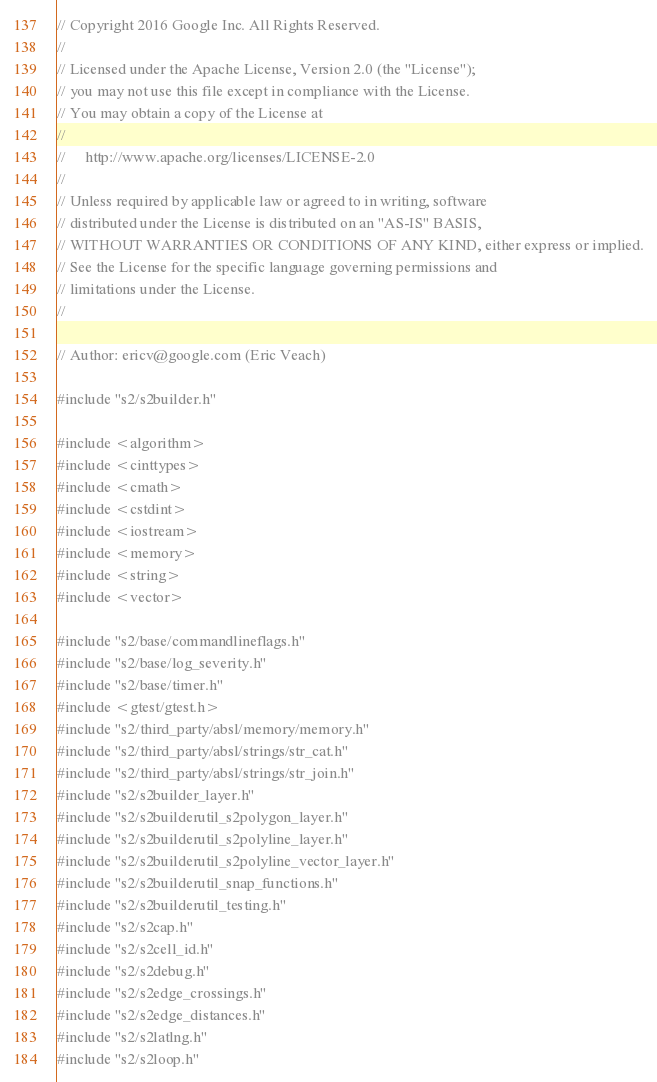Convert code to text. <code><loc_0><loc_0><loc_500><loc_500><_C++_>// Copyright 2016 Google Inc. All Rights Reserved.
//
// Licensed under the Apache License, Version 2.0 (the "License");
// you may not use this file except in compliance with the License.
// You may obtain a copy of the License at
//
//     http://www.apache.org/licenses/LICENSE-2.0
//
// Unless required by applicable law or agreed to in writing, software
// distributed under the License is distributed on an "AS-IS" BASIS,
// WITHOUT WARRANTIES OR CONDITIONS OF ANY KIND, either express or implied.
// See the License for the specific language governing permissions and
// limitations under the License.
//

// Author: ericv@google.com (Eric Veach)

#include "s2/s2builder.h"

#include <algorithm>
#include <cinttypes>
#include <cmath>
#include <cstdint>
#include <iostream>
#include <memory>
#include <string>
#include <vector>

#include "s2/base/commandlineflags.h"
#include "s2/base/log_severity.h"
#include "s2/base/timer.h"
#include <gtest/gtest.h>
#include "s2/third_party/absl/memory/memory.h"
#include "s2/third_party/absl/strings/str_cat.h"
#include "s2/third_party/absl/strings/str_join.h"
#include "s2/s2builder_layer.h"
#include "s2/s2builderutil_s2polygon_layer.h"
#include "s2/s2builderutil_s2polyline_layer.h"
#include "s2/s2builderutil_s2polyline_vector_layer.h"
#include "s2/s2builderutil_snap_functions.h"
#include "s2/s2builderutil_testing.h"
#include "s2/s2cap.h"
#include "s2/s2cell_id.h"
#include "s2/s2debug.h"
#include "s2/s2edge_crossings.h"
#include "s2/s2edge_distances.h"
#include "s2/s2latlng.h"
#include "s2/s2loop.h"</code> 